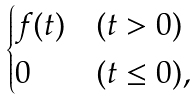<formula> <loc_0><loc_0><loc_500><loc_500>\begin{cases} f ( t ) & ( t > 0 ) \\ 0 & ( t \leq 0 ) , \end{cases}</formula> 